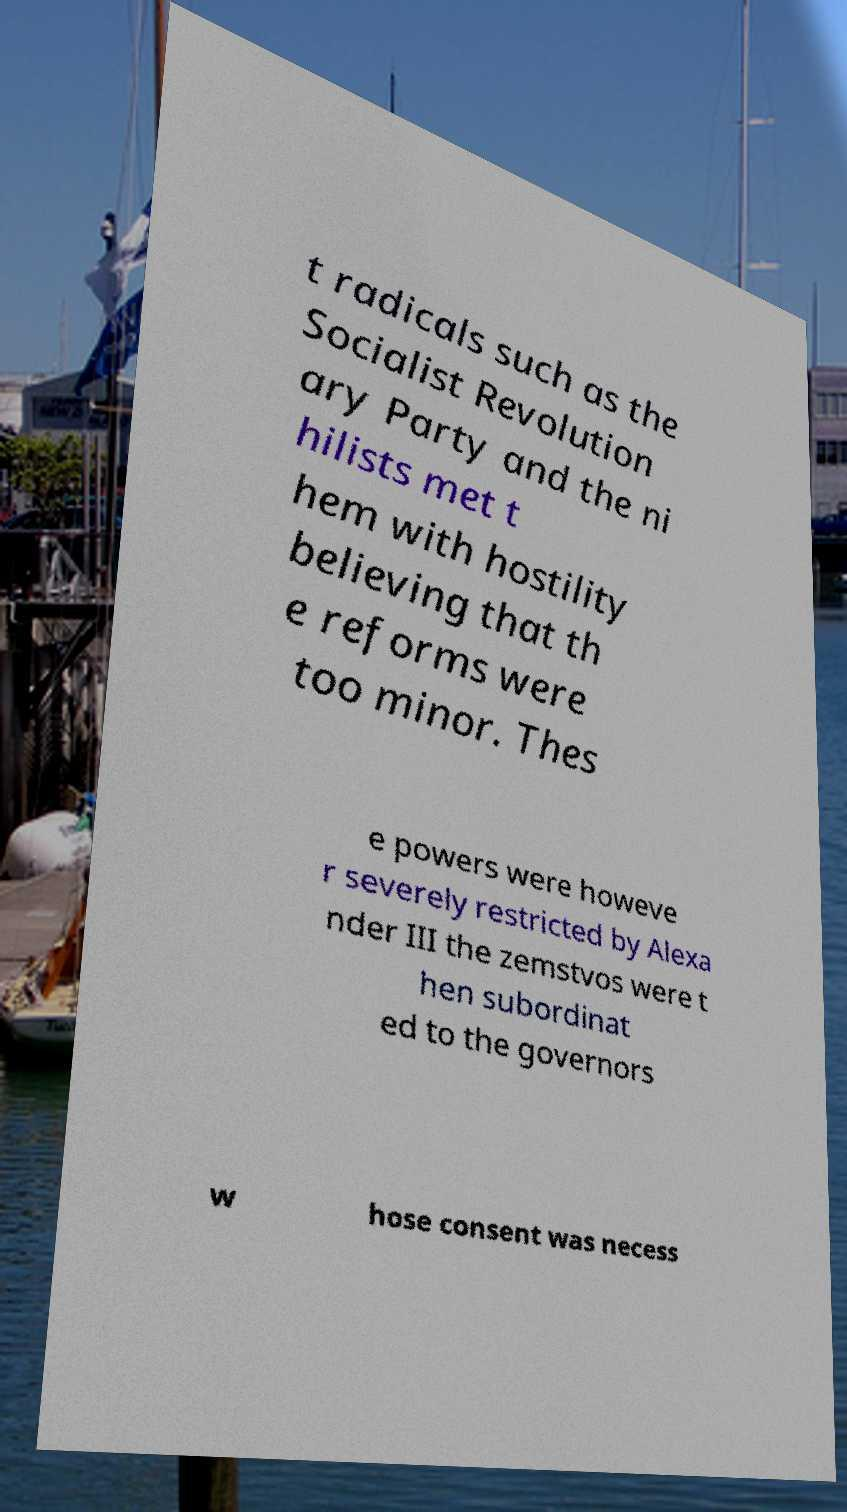Could you assist in decoding the text presented in this image and type it out clearly? t radicals such as the Socialist Revolution ary Party and the ni hilists met t hem with hostility believing that th e reforms were too minor. Thes e powers were howeve r severely restricted by Alexa nder III the zemstvos were t hen subordinat ed to the governors w hose consent was necess 